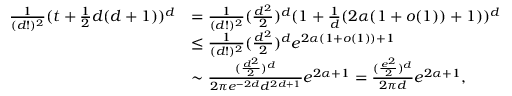Convert formula to latex. <formula><loc_0><loc_0><loc_500><loc_500>\begin{array} { r l } { \frac { 1 } { ( d ! ) ^ { 2 } } ( t + \frac { 1 } { 2 } d ( d + 1 ) ) ^ { d } } & { = \frac { 1 } { ( d ! ) ^ { 2 } } ( \frac { d ^ { 2 } } { 2 } ) ^ { d } ( 1 + \frac { 1 } { d } ( 2 \alpha ( 1 + o ( 1 ) ) + 1 ) ) ^ { d } } \\ & { \leq \frac { 1 } { ( d ! ) ^ { 2 } } ( \frac { d ^ { 2 } } { 2 } ) ^ { d } e ^ { 2 \alpha ( 1 + o ( 1 ) ) + 1 } } \\ & { \sim \frac { ( \frac { d ^ { 2 } } { 2 } ) ^ { d } } { 2 \pi e ^ { - 2 d } d ^ { 2 d + 1 } } e ^ { 2 \alpha + 1 } = \frac { ( \frac { e ^ { 2 } } { 2 } ) ^ { d } } { 2 \pi d } e ^ { 2 \alpha + 1 } , } \end{array}</formula> 